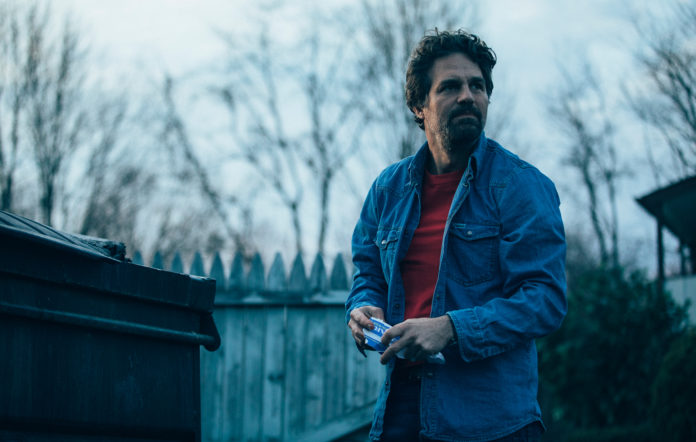Imagine this image is from a movie. What kind of movie might it be from? This image could easily be from a suspense thriller or a mystery drama. The man's serious and focused expression, coupled with the suburban yet somewhat isolated setting, suggests a plot involving personal secrets, investigations, or a revelation about his past. Describe a scene where this moment is a turning point in the movie. In the movie, this would be the pivotal scene where the protagonist, Alex, receives a crucial piece of information that leads him to this location. The dim lighting and eerie quietness set the stage as he approaches the dumpster, uncovering a hidden document that reveals the true extent of the antagonist's plans. This discovery puts him in immediate danger but also arms him with the knowledge needed to thwart the impending disaster. His serious expression captures the weight of this revelation and the urgency of the situation. What if this image was from a sci-fi movie? How would the narrative change? If this were from a sci-fi movie, the image might depict Dr. Nathan Wells, a brilliant but troubled scientist who has just discovered a groundbreaking yet perilous invention: a device capable of manipulating time. His serious gaze and the suburban setting hide the tension of knowing his invention could fall into the wrong hands. The dumpster might actually be concealing a high-tech temporal gateway he's created in secret. The trees and fence could serve as a backdrop to an impending chase, where time-traveling agents from the future arrive to capture or recruit him for their nefarious purposes. Nathan must then navigate the complexities of his creation, grappling with ethical dilemmas and the threat of temporal anomalies triggered by his device. 